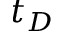Convert formula to latex. <formula><loc_0><loc_0><loc_500><loc_500>t _ { D }</formula> 